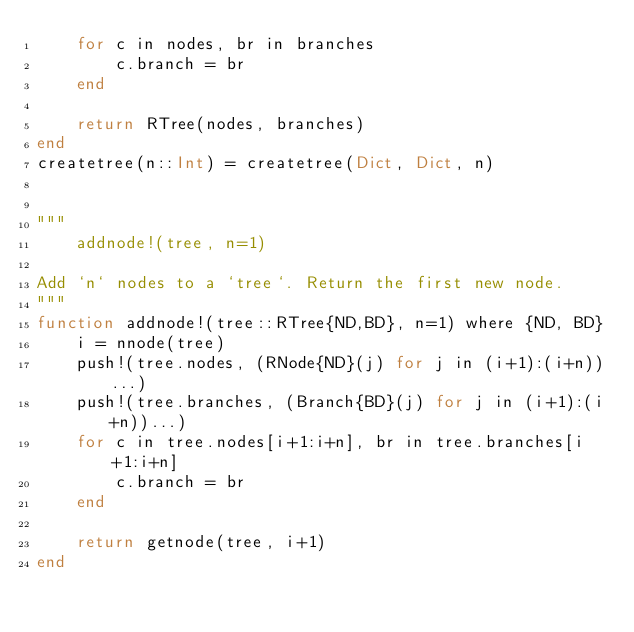Convert code to text. <code><loc_0><loc_0><loc_500><loc_500><_Julia_>    for c in nodes, br in branches
        c.branch = br
    end

    return RTree(nodes, branches)
end
createtree(n::Int) = createtree(Dict, Dict, n)


"""
    addnode!(tree, n=1)

Add `n` nodes to a `tree`. Return the first new node.
"""
function addnode!(tree::RTree{ND,BD}, n=1) where {ND, BD}
    i = nnode(tree)
    push!(tree.nodes, (RNode{ND}(j) for j in (i+1):(i+n))...)
    push!(tree.branches, (Branch{BD}(j) for j in (i+1):(i+n))...)
    for c in tree.nodes[i+1:i+n], br in tree.branches[i+1:i+n]
        c.branch = br
    end

    return getnode(tree, i+1)
end

</code> 